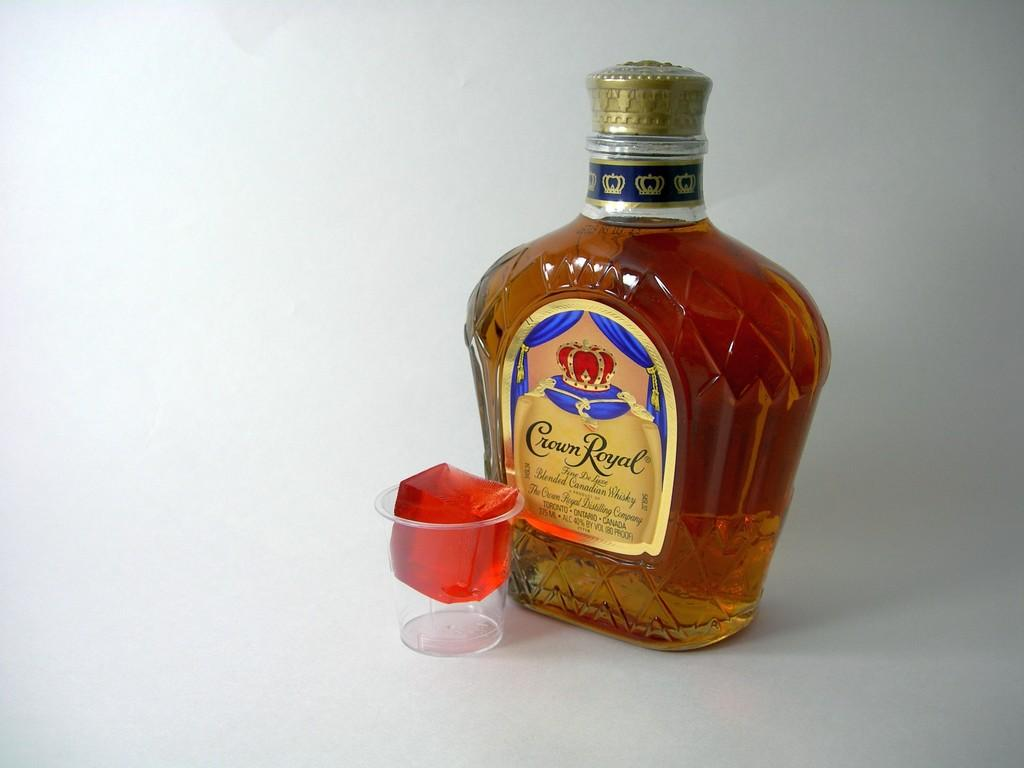<image>
Give a short and clear explanation of the subsequent image. The bottle of Crown Royal is complements by jello in a shot glass. 